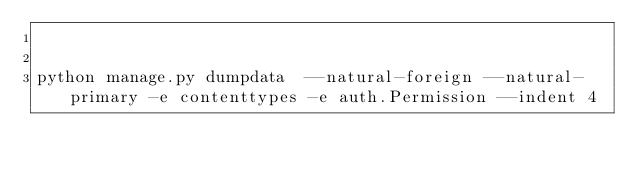<code> <loc_0><loc_0><loc_500><loc_500><_Bash_>

python manage.py dumpdata  --natural-foreign --natural-primary -e contenttypes -e auth.Permission --indent 4

</code> 